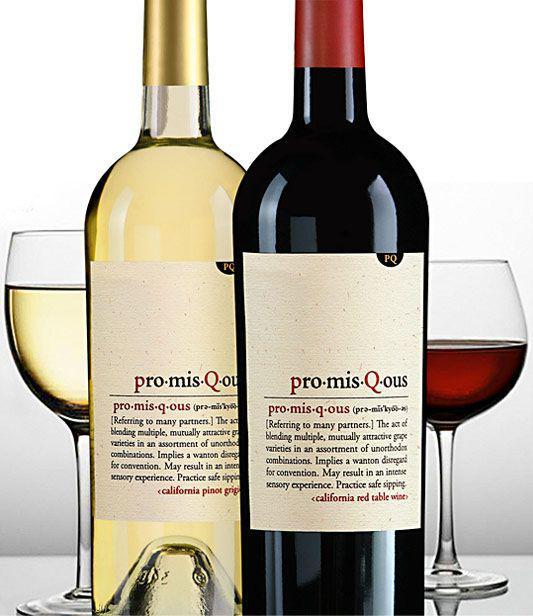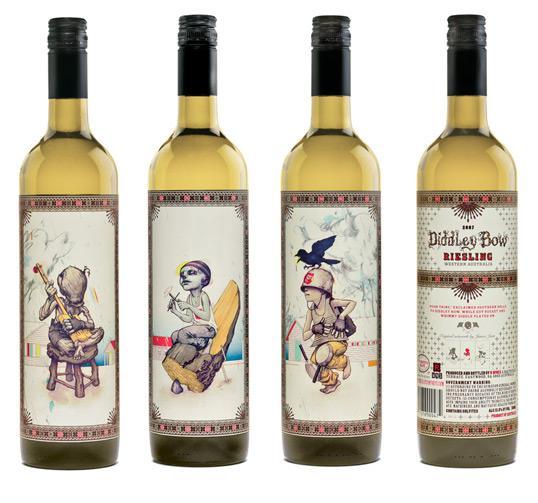The first image is the image on the left, the second image is the image on the right. Assess this claim about the two images: "There is one wine bottle in the left image.". Correct or not? Answer yes or no. No. The first image is the image on the left, the second image is the image on the right. For the images shown, is this caption "Exactly one bottle of wine is standing in one image." true? Answer yes or no. No. 